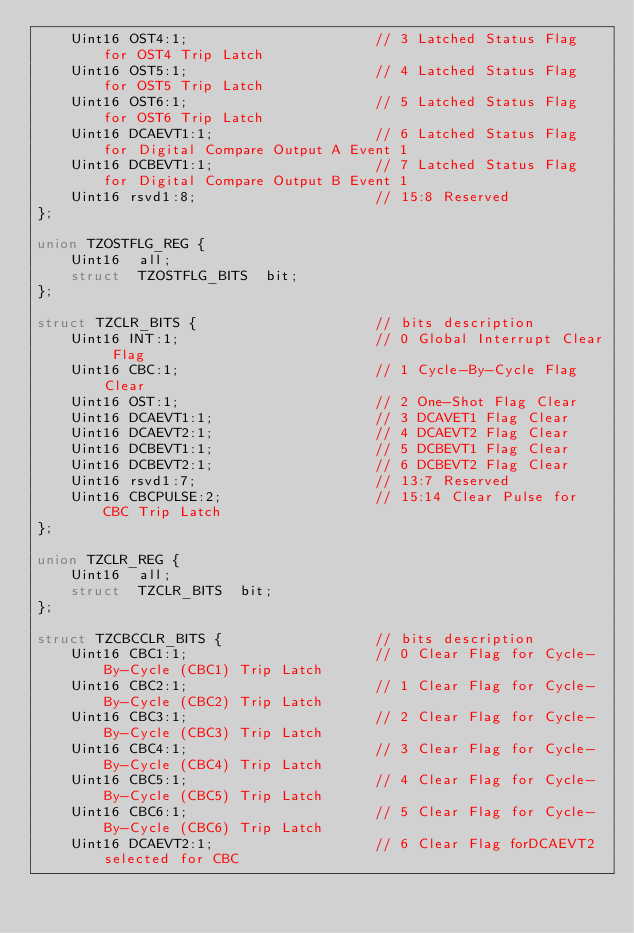Convert code to text. <code><loc_0><loc_0><loc_500><loc_500><_C_>    Uint16 OST4:1;                      // 3 Latched Status Flag for OST4 Trip Latch
    Uint16 OST5:1;                      // 4 Latched Status Flag for OST5 Trip Latch
    Uint16 OST6:1;                      // 5 Latched Status Flag for OST6 Trip Latch
    Uint16 DCAEVT1:1;                   // 6 Latched Status Flag for Digital Compare Output A Event 1
    Uint16 DCBEVT1:1;                   // 7 Latched Status Flag for Digital Compare Output B Event 1
    Uint16 rsvd1:8;                     // 15:8 Reserved
};

union TZOSTFLG_REG {
    Uint16  all;
    struct  TZOSTFLG_BITS  bit;
};

struct TZCLR_BITS {                     // bits description
    Uint16 INT:1;                       // 0 Global Interrupt Clear Flag
    Uint16 CBC:1;                       // 1 Cycle-By-Cycle Flag Clear
    Uint16 OST:1;                       // 2 One-Shot Flag Clear
    Uint16 DCAEVT1:1;                   // 3 DCAVET1 Flag Clear
    Uint16 DCAEVT2:1;                   // 4 DCAEVT2 Flag Clear
    Uint16 DCBEVT1:1;                   // 5 DCBEVT1 Flag Clear
    Uint16 DCBEVT2:1;                   // 6 DCBEVT2 Flag Clear
    Uint16 rsvd1:7;                     // 13:7 Reserved
    Uint16 CBCPULSE:2;                  // 15:14 Clear Pulse for CBC Trip Latch
};

union TZCLR_REG {
    Uint16  all;
    struct  TZCLR_BITS  bit;
};

struct TZCBCCLR_BITS {                  // bits description
    Uint16 CBC1:1;                      // 0 Clear Flag for Cycle-By-Cycle (CBC1) Trip Latch
    Uint16 CBC2:1;                      // 1 Clear Flag for Cycle-By-Cycle (CBC2) Trip Latch
    Uint16 CBC3:1;                      // 2 Clear Flag for Cycle-By-Cycle (CBC3) Trip Latch
    Uint16 CBC4:1;                      // 3 Clear Flag for Cycle-By-Cycle (CBC4) Trip Latch
    Uint16 CBC5:1;                      // 4 Clear Flag for Cycle-By-Cycle (CBC5) Trip Latch
    Uint16 CBC6:1;                      // 5 Clear Flag for Cycle-By-Cycle (CBC6) Trip Latch
    Uint16 DCAEVT2:1;                   // 6 Clear Flag forDCAEVT2 selected for CBC</code> 